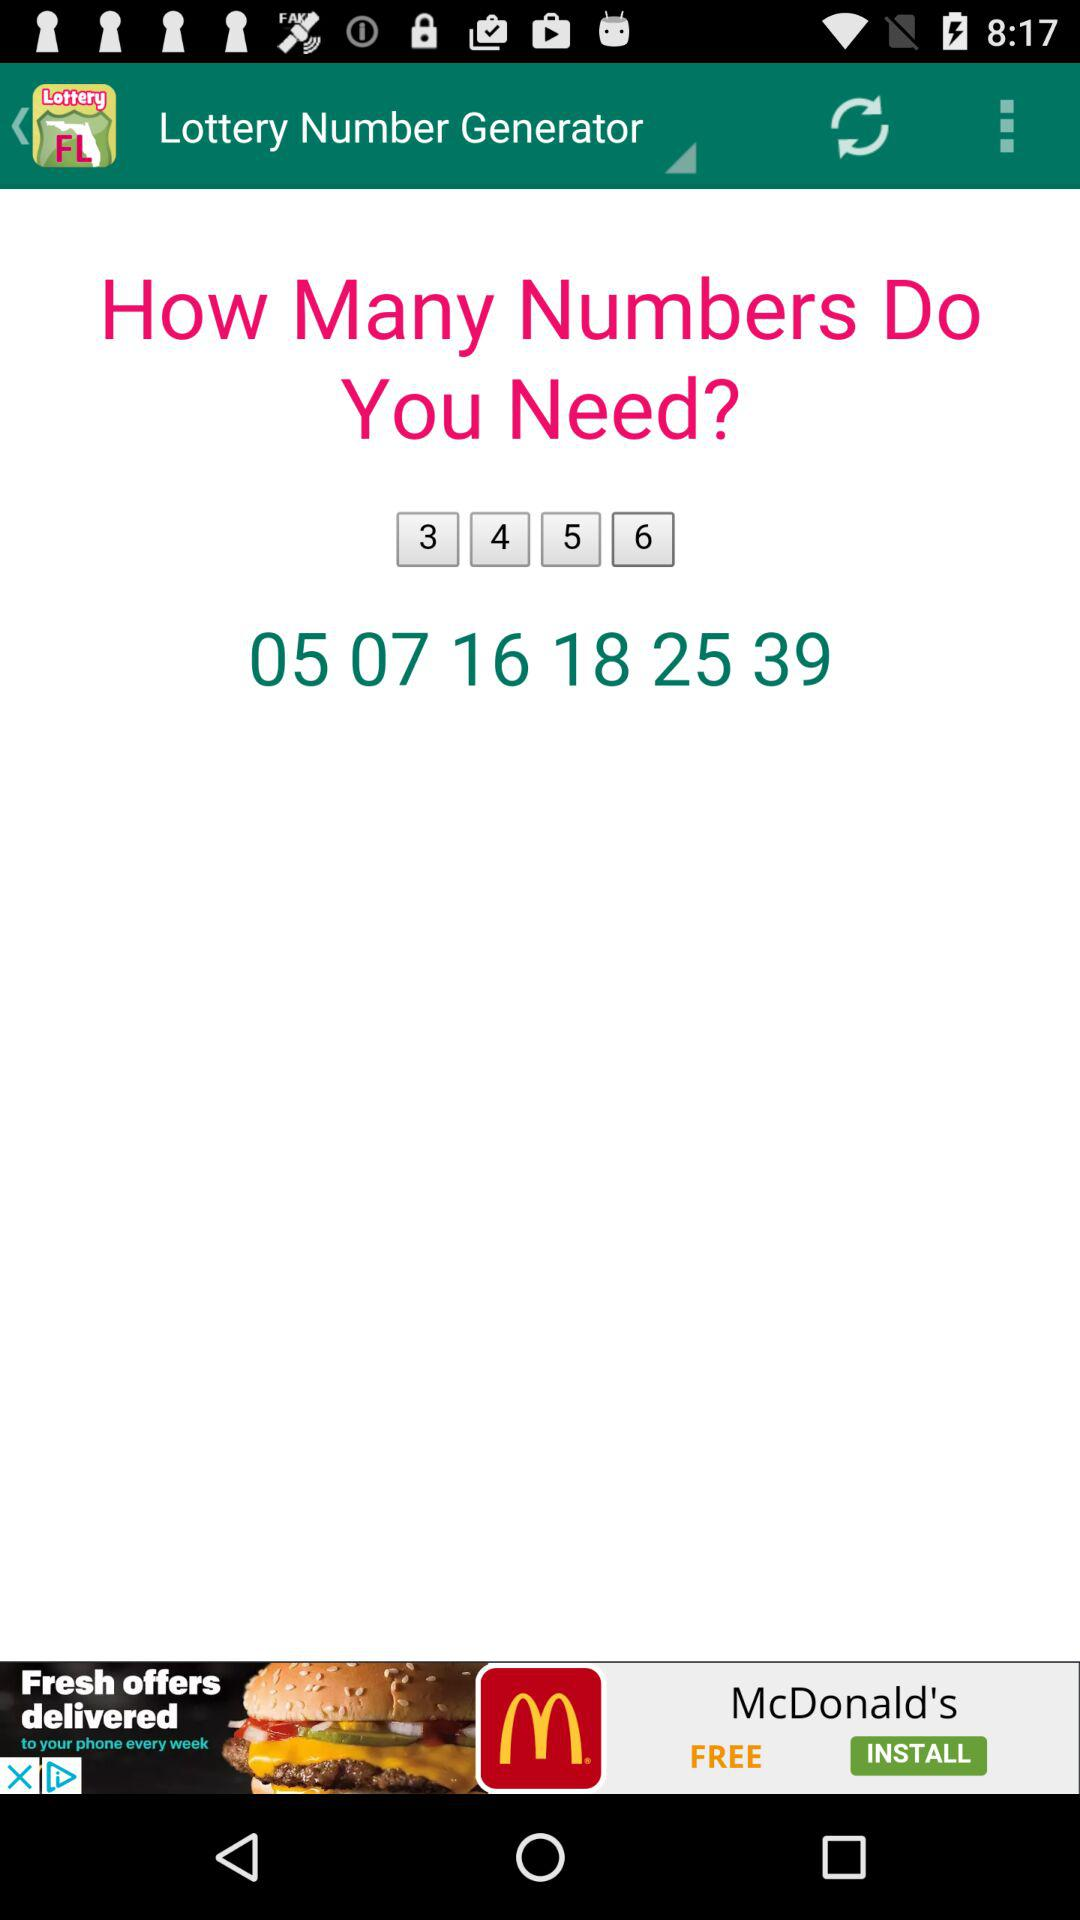What is the name of the application? The name of the application is "Florida Lottery Results". 